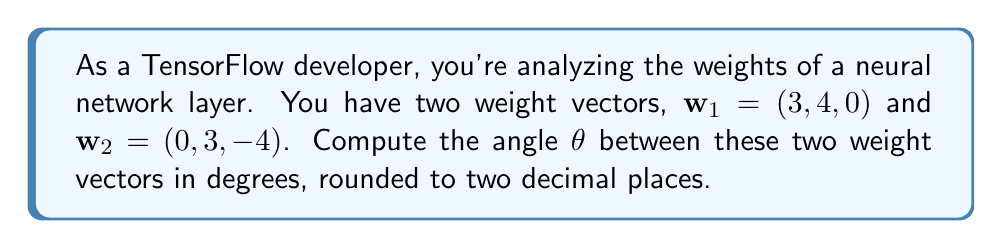Help me with this question. To find the angle between two vectors, we can use the dot product formula:

$$\cos \theta = \frac{\mathbf{w}_1 \cdot \mathbf{w}_2}{|\mathbf{w}_1| |\mathbf{w}_2|}$$

Let's break this down step-by-step:

1. Calculate the dot product $\mathbf{w}_1 \cdot \mathbf{w}_2$:
   $$\mathbf{w}_1 \cdot \mathbf{w}_2 = (3)(0) + (4)(3) + (0)(-4) = 0 + 12 + 0 = 12$$

2. Calculate the magnitudes of the vectors:
   $$|\mathbf{w}_1| = \sqrt{3^2 + 4^2 + 0^2} = \sqrt{9 + 16} = \sqrt{25} = 5$$
   $$|\mathbf{w}_2| = \sqrt{0^2 + 3^2 + (-4)^2} = \sqrt{9 + 16} = \sqrt{25} = 5$$

3. Substitute these values into the formula:
   $$\cos \theta = \frac{12}{(5)(5)} = \frac{12}{25} = 0.48$$

4. To find $\theta$, we need to take the inverse cosine (arccos) of both sides:
   $$\theta = \arccos(0.48)$$

5. Convert from radians to degrees:
   $$\theta = \arccos(0.48) \cdot \frac{180}{\pi} \approx 61.31°$$

6. Round to two decimal places:
   $$\theta \approx 61.31°$$
Answer: The angle between the two weight vectors is approximately 61.31°. 